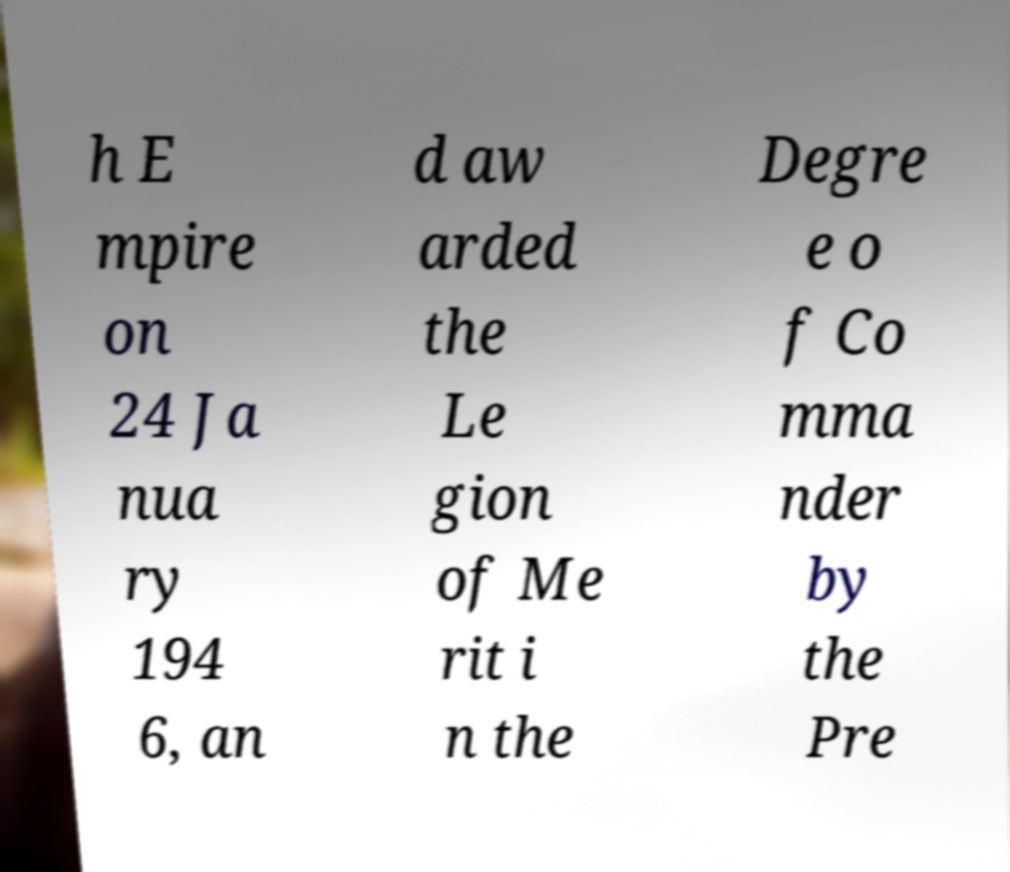Please read and relay the text visible in this image. What does it say? h E mpire on 24 Ja nua ry 194 6, an d aw arded the Le gion of Me rit i n the Degre e o f Co mma nder by the Pre 